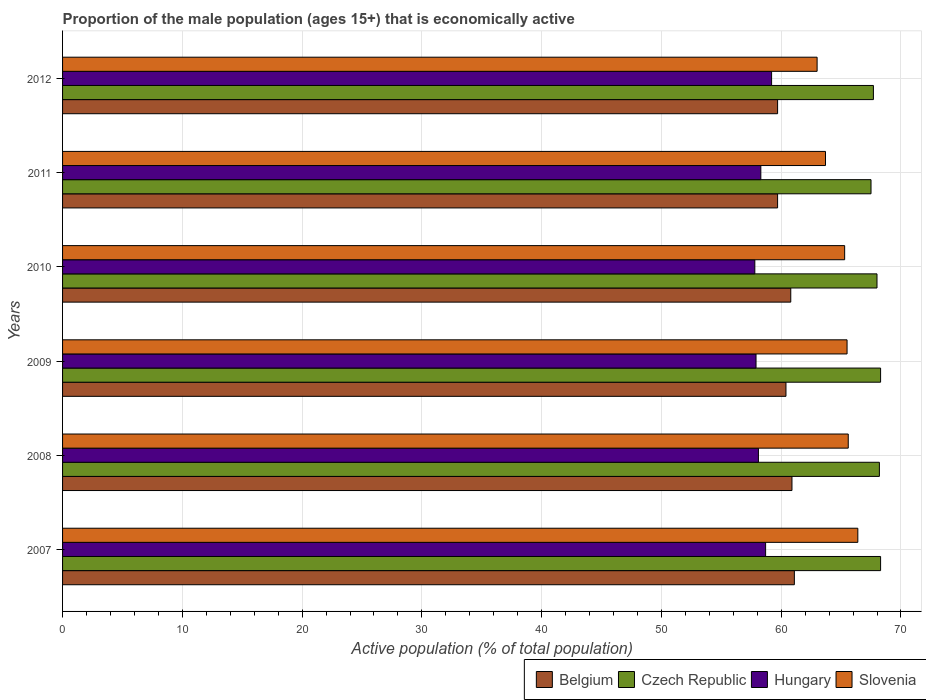Are the number of bars per tick equal to the number of legend labels?
Offer a terse response. Yes. How many bars are there on the 4th tick from the top?
Ensure brevity in your answer.  4. How many bars are there on the 6th tick from the bottom?
Keep it short and to the point. 4. What is the label of the 5th group of bars from the top?
Make the answer very short. 2008. In how many cases, is the number of bars for a given year not equal to the number of legend labels?
Offer a very short reply. 0. What is the proportion of the male population that is economically active in Slovenia in 2010?
Offer a terse response. 65.3. Across all years, what is the maximum proportion of the male population that is economically active in Czech Republic?
Keep it short and to the point. 68.3. Across all years, what is the minimum proportion of the male population that is economically active in Hungary?
Ensure brevity in your answer.  57.8. In which year was the proportion of the male population that is economically active in Slovenia minimum?
Your answer should be compact. 2012. What is the total proportion of the male population that is economically active in Belgium in the graph?
Offer a terse response. 362.6. What is the difference between the proportion of the male population that is economically active in Czech Republic in 2009 and that in 2012?
Offer a very short reply. 0.6. What is the difference between the proportion of the male population that is economically active in Slovenia in 2010 and the proportion of the male population that is economically active in Czech Republic in 2011?
Offer a terse response. -2.2. What is the average proportion of the male population that is economically active in Belgium per year?
Keep it short and to the point. 60.43. In the year 2011, what is the difference between the proportion of the male population that is economically active in Czech Republic and proportion of the male population that is economically active in Belgium?
Provide a short and direct response. 7.8. In how many years, is the proportion of the male population that is economically active in Hungary greater than 36 %?
Offer a very short reply. 6. What is the ratio of the proportion of the male population that is economically active in Hungary in 2011 to that in 2012?
Make the answer very short. 0.98. Is the proportion of the male population that is economically active in Slovenia in 2007 less than that in 2011?
Keep it short and to the point. No. What is the difference between the highest and the second highest proportion of the male population that is economically active in Hungary?
Keep it short and to the point. 0.5. What is the difference between the highest and the lowest proportion of the male population that is economically active in Belgium?
Your response must be concise. 1.4. What does the 1st bar from the bottom in 2012 represents?
Your answer should be compact. Belgium. Is it the case that in every year, the sum of the proportion of the male population that is economically active in Czech Republic and proportion of the male population that is economically active in Hungary is greater than the proportion of the male population that is economically active in Belgium?
Ensure brevity in your answer.  Yes. How many bars are there?
Your answer should be compact. 24. How many years are there in the graph?
Your response must be concise. 6. What is the difference between two consecutive major ticks on the X-axis?
Your answer should be compact. 10. Does the graph contain grids?
Keep it short and to the point. Yes. How many legend labels are there?
Ensure brevity in your answer.  4. How are the legend labels stacked?
Ensure brevity in your answer.  Horizontal. What is the title of the graph?
Ensure brevity in your answer.  Proportion of the male population (ages 15+) that is economically active. What is the label or title of the X-axis?
Your answer should be very brief. Active population (% of total population). What is the label or title of the Y-axis?
Ensure brevity in your answer.  Years. What is the Active population (% of total population) in Belgium in 2007?
Your answer should be compact. 61.1. What is the Active population (% of total population) in Czech Republic in 2007?
Give a very brief answer. 68.3. What is the Active population (% of total population) of Hungary in 2007?
Ensure brevity in your answer.  58.7. What is the Active population (% of total population) in Slovenia in 2007?
Ensure brevity in your answer.  66.4. What is the Active population (% of total population) in Belgium in 2008?
Provide a succinct answer. 60.9. What is the Active population (% of total population) of Czech Republic in 2008?
Your answer should be very brief. 68.2. What is the Active population (% of total population) in Hungary in 2008?
Keep it short and to the point. 58.1. What is the Active population (% of total population) of Slovenia in 2008?
Ensure brevity in your answer.  65.6. What is the Active population (% of total population) of Belgium in 2009?
Offer a very short reply. 60.4. What is the Active population (% of total population) in Czech Republic in 2009?
Ensure brevity in your answer.  68.3. What is the Active population (% of total population) of Hungary in 2009?
Your response must be concise. 57.9. What is the Active population (% of total population) in Slovenia in 2009?
Make the answer very short. 65.5. What is the Active population (% of total population) in Belgium in 2010?
Keep it short and to the point. 60.8. What is the Active population (% of total population) in Hungary in 2010?
Offer a very short reply. 57.8. What is the Active population (% of total population) in Slovenia in 2010?
Make the answer very short. 65.3. What is the Active population (% of total population) of Belgium in 2011?
Provide a succinct answer. 59.7. What is the Active population (% of total population) of Czech Republic in 2011?
Provide a short and direct response. 67.5. What is the Active population (% of total population) of Hungary in 2011?
Offer a terse response. 58.3. What is the Active population (% of total population) of Slovenia in 2011?
Your answer should be very brief. 63.7. What is the Active population (% of total population) in Belgium in 2012?
Your answer should be very brief. 59.7. What is the Active population (% of total population) in Czech Republic in 2012?
Offer a terse response. 67.7. What is the Active population (% of total population) of Hungary in 2012?
Give a very brief answer. 59.2. What is the Active population (% of total population) in Slovenia in 2012?
Give a very brief answer. 63. Across all years, what is the maximum Active population (% of total population) of Belgium?
Offer a very short reply. 61.1. Across all years, what is the maximum Active population (% of total population) in Czech Republic?
Ensure brevity in your answer.  68.3. Across all years, what is the maximum Active population (% of total population) of Hungary?
Your answer should be very brief. 59.2. Across all years, what is the maximum Active population (% of total population) in Slovenia?
Your answer should be very brief. 66.4. Across all years, what is the minimum Active population (% of total population) in Belgium?
Ensure brevity in your answer.  59.7. Across all years, what is the minimum Active population (% of total population) of Czech Republic?
Give a very brief answer. 67.5. Across all years, what is the minimum Active population (% of total population) in Hungary?
Provide a short and direct response. 57.8. Across all years, what is the minimum Active population (% of total population) of Slovenia?
Provide a succinct answer. 63. What is the total Active population (% of total population) in Belgium in the graph?
Provide a short and direct response. 362.6. What is the total Active population (% of total population) of Czech Republic in the graph?
Your response must be concise. 408. What is the total Active population (% of total population) in Hungary in the graph?
Give a very brief answer. 350. What is the total Active population (% of total population) in Slovenia in the graph?
Your answer should be compact. 389.5. What is the difference between the Active population (% of total population) in Hungary in 2007 and that in 2008?
Offer a terse response. 0.6. What is the difference between the Active population (% of total population) of Belgium in 2007 and that in 2009?
Provide a succinct answer. 0.7. What is the difference between the Active population (% of total population) in Belgium in 2007 and that in 2010?
Give a very brief answer. 0.3. What is the difference between the Active population (% of total population) in Slovenia in 2007 and that in 2010?
Provide a short and direct response. 1.1. What is the difference between the Active population (% of total population) in Belgium in 2007 and that in 2011?
Ensure brevity in your answer.  1.4. What is the difference between the Active population (% of total population) of Czech Republic in 2007 and that in 2011?
Provide a succinct answer. 0.8. What is the difference between the Active population (% of total population) in Hungary in 2007 and that in 2011?
Provide a short and direct response. 0.4. What is the difference between the Active population (% of total population) of Belgium in 2007 and that in 2012?
Your answer should be very brief. 1.4. What is the difference between the Active population (% of total population) in Czech Republic in 2007 and that in 2012?
Provide a succinct answer. 0.6. What is the difference between the Active population (% of total population) of Hungary in 2007 and that in 2012?
Offer a terse response. -0.5. What is the difference between the Active population (% of total population) in Slovenia in 2007 and that in 2012?
Offer a very short reply. 3.4. What is the difference between the Active population (% of total population) in Belgium in 2008 and that in 2010?
Make the answer very short. 0.1. What is the difference between the Active population (% of total population) of Belgium in 2008 and that in 2011?
Keep it short and to the point. 1.2. What is the difference between the Active population (% of total population) in Czech Republic in 2008 and that in 2011?
Provide a succinct answer. 0.7. What is the difference between the Active population (% of total population) of Slovenia in 2008 and that in 2011?
Provide a succinct answer. 1.9. What is the difference between the Active population (% of total population) of Belgium in 2008 and that in 2012?
Your response must be concise. 1.2. What is the difference between the Active population (% of total population) in Czech Republic in 2008 and that in 2012?
Your response must be concise. 0.5. What is the difference between the Active population (% of total population) in Slovenia in 2008 and that in 2012?
Ensure brevity in your answer.  2.6. What is the difference between the Active population (% of total population) in Hungary in 2009 and that in 2010?
Make the answer very short. 0.1. What is the difference between the Active population (% of total population) in Czech Republic in 2009 and that in 2011?
Offer a terse response. 0.8. What is the difference between the Active population (% of total population) in Czech Republic in 2009 and that in 2012?
Offer a very short reply. 0.6. What is the difference between the Active population (% of total population) in Hungary in 2009 and that in 2012?
Provide a succinct answer. -1.3. What is the difference between the Active population (% of total population) of Belgium in 2010 and that in 2011?
Keep it short and to the point. 1.1. What is the difference between the Active population (% of total population) of Hungary in 2010 and that in 2011?
Provide a short and direct response. -0.5. What is the difference between the Active population (% of total population) in Belgium in 2010 and that in 2012?
Ensure brevity in your answer.  1.1. What is the difference between the Active population (% of total population) in Czech Republic in 2010 and that in 2012?
Your answer should be compact. 0.3. What is the difference between the Active population (% of total population) in Hungary in 2010 and that in 2012?
Keep it short and to the point. -1.4. What is the difference between the Active population (% of total population) of Belgium in 2011 and that in 2012?
Offer a very short reply. 0. What is the difference between the Active population (% of total population) of Czech Republic in 2011 and that in 2012?
Ensure brevity in your answer.  -0.2. What is the difference between the Active population (% of total population) in Slovenia in 2011 and that in 2012?
Make the answer very short. 0.7. What is the difference between the Active population (% of total population) of Belgium in 2007 and the Active population (% of total population) of Czech Republic in 2008?
Provide a succinct answer. -7.1. What is the difference between the Active population (% of total population) in Belgium in 2007 and the Active population (% of total population) in Slovenia in 2008?
Provide a short and direct response. -4.5. What is the difference between the Active population (% of total population) of Czech Republic in 2007 and the Active population (% of total population) of Slovenia in 2008?
Offer a very short reply. 2.7. What is the difference between the Active population (% of total population) in Belgium in 2007 and the Active population (% of total population) in Czech Republic in 2009?
Your answer should be compact. -7.2. What is the difference between the Active population (% of total population) in Belgium in 2007 and the Active population (% of total population) in Slovenia in 2009?
Offer a terse response. -4.4. What is the difference between the Active population (% of total population) in Czech Republic in 2007 and the Active population (% of total population) in Hungary in 2009?
Make the answer very short. 10.4. What is the difference between the Active population (% of total population) in Czech Republic in 2007 and the Active population (% of total population) in Slovenia in 2009?
Your answer should be compact. 2.8. What is the difference between the Active population (% of total population) in Belgium in 2007 and the Active population (% of total population) in Czech Republic in 2010?
Offer a very short reply. -6.9. What is the difference between the Active population (% of total population) of Hungary in 2007 and the Active population (% of total population) of Slovenia in 2010?
Your answer should be very brief. -6.6. What is the difference between the Active population (% of total population) of Czech Republic in 2007 and the Active population (% of total population) of Hungary in 2011?
Give a very brief answer. 10. What is the difference between the Active population (% of total population) in Czech Republic in 2007 and the Active population (% of total population) in Slovenia in 2011?
Offer a terse response. 4.6. What is the difference between the Active population (% of total population) of Hungary in 2007 and the Active population (% of total population) of Slovenia in 2011?
Give a very brief answer. -5. What is the difference between the Active population (% of total population) in Belgium in 2007 and the Active population (% of total population) in Czech Republic in 2012?
Your answer should be compact. -6.6. What is the difference between the Active population (% of total population) in Belgium in 2007 and the Active population (% of total population) in Hungary in 2012?
Offer a very short reply. 1.9. What is the difference between the Active population (% of total population) in Belgium in 2007 and the Active population (% of total population) in Slovenia in 2012?
Give a very brief answer. -1.9. What is the difference between the Active population (% of total population) in Hungary in 2007 and the Active population (% of total population) in Slovenia in 2012?
Provide a short and direct response. -4.3. What is the difference between the Active population (% of total population) in Belgium in 2008 and the Active population (% of total population) in Czech Republic in 2009?
Offer a very short reply. -7.4. What is the difference between the Active population (% of total population) of Belgium in 2008 and the Active population (% of total population) of Slovenia in 2009?
Your response must be concise. -4.6. What is the difference between the Active population (% of total population) of Czech Republic in 2008 and the Active population (% of total population) of Hungary in 2009?
Offer a very short reply. 10.3. What is the difference between the Active population (% of total population) of Belgium in 2008 and the Active population (% of total population) of Czech Republic in 2010?
Provide a short and direct response. -7.1. What is the difference between the Active population (% of total population) in Belgium in 2008 and the Active population (% of total population) in Hungary in 2010?
Provide a succinct answer. 3.1. What is the difference between the Active population (% of total population) in Belgium in 2008 and the Active population (% of total population) in Slovenia in 2010?
Keep it short and to the point. -4.4. What is the difference between the Active population (% of total population) in Czech Republic in 2008 and the Active population (% of total population) in Hungary in 2010?
Your response must be concise. 10.4. What is the difference between the Active population (% of total population) of Hungary in 2008 and the Active population (% of total population) of Slovenia in 2010?
Keep it short and to the point. -7.2. What is the difference between the Active population (% of total population) in Belgium in 2008 and the Active population (% of total population) in Hungary in 2011?
Offer a very short reply. 2.6. What is the difference between the Active population (% of total population) in Czech Republic in 2008 and the Active population (% of total population) in Slovenia in 2011?
Offer a very short reply. 4.5. What is the difference between the Active population (% of total population) in Hungary in 2008 and the Active population (% of total population) in Slovenia in 2011?
Give a very brief answer. -5.6. What is the difference between the Active population (% of total population) in Belgium in 2008 and the Active population (% of total population) in Czech Republic in 2012?
Offer a terse response. -6.8. What is the difference between the Active population (% of total population) in Belgium in 2008 and the Active population (% of total population) in Slovenia in 2012?
Make the answer very short. -2.1. What is the difference between the Active population (% of total population) of Czech Republic in 2008 and the Active population (% of total population) of Hungary in 2012?
Offer a terse response. 9. What is the difference between the Active population (% of total population) in Belgium in 2009 and the Active population (% of total population) in Czech Republic in 2010?
Provide a short and direct response. -7.6. What is the difference between the Active population (% of total population) in Belgium in 2009 and the Active population (% of total population) in Slovenia in 2010?
Offer a terse response. -4.9. What is the difference between the Active population (% of total population) of Czech Republic in 2009 and the Active population (% of total population) of Hungary in 2010?
Offer a terse response. 10.5. What is the difference between the Active population (% of total population) of Czech Republic in 2009 and the Active population (% of total population) of Slovenia in 2010?
Make the answer very short. 3. What is the difference between the Active population (% of total population) in Belgium in 2009 and the Active population (% of total population) in Hungary in 2011?
Provide a succinct answer. 2.1. What is the difference between the Active population (% of total population) of Czech Republic in 2009 and the Active population (% of total population) of Slovenia in 2011?
Provide a short and direct response. 4.6. What is the difference between the Active population (% of total population) of Belgium in 2009 and the Active population (% of total population) of Slovenia in 2012?
Provide a succinct answer. -2.6. What is the difference between the Active population (% of total population) in Czech Republic in 2009 and the Active population (% of total population) in Hungary in 2012?
Offer a terse response. 9.1. What is the difference between the Active population (% of total population) of Belgium in 2010 and the Active population (% of total population) of Slovenia in 2011?
Offer a terse response. -2.9. What is the difference between the Active population (% of total population) in Czech Republic in 2010 and the Active population (% of total population) in Hungary in 2011?
Ensure brevity in your answer.  9.7. What is the difference between the Active population (% of total population) in Czech Republic in 2010 and the Active population (% of total population) in Slovenia in 2011?
Your response must be concise. 4.3. What is the difference between the Active population (% of total population) in Hungary in 2010 and the Active population (% of total population) in Slovenia in 2011?
Your response must be concise. -5.9. What is the difference between the Active population (% of total population) of Belgium in 2010 and the Active population (% of total population) of Czech Republic in 2012?
Provide a succinct answer. -6.9. What is the difference between the Active population (% of total population) of Belgium in 2010 and the Active population (% of total population) of Hungary in 2012?
Offer a very short reply. 1.6. What is the difference between the Active population (% of total population) of Czech Republic in 2010 and the Active population (% of total population) of Slovenia in 2012?
Keep it short and to the point. 5. What is the difference between the Active population (% of total population) in Hungary in 2010 and the Active population (% of total population) in Slovenia in 2012?
Provide a succinct answer. -5.2. What is the difference between the Active population (% of total population) in Belgium in 2011 and the Active population (% of total population) in Slovenia in 2012?
Provide a short and direct response. -3.3. What is the difference between the Active population (% of total population) in Czech Republic in 2011 and the Active population (% of total population) in Hungary in 2012?
Your answer should be compact. 8.3. What is the average Active population (% of total population) in Belgium per year?
Make the answer very short. 60.43. What is the average Active population (% of total population) of Czech Republic per year?
Provide a succinct answer. 68. What is the average Active population (% of total population) of Hungary per year?
Keep it short and to the point. 58.33. What is the average Active population (% of total population) of Slovenia per year?
Provide a short and direct response. 64.92. In the year 2007, what is the difference between the Active population (% of total population) of Belgium and Active population (% of total population) of Hungary?
Your answer should be compact. 2.4. In the year 2007, what is the difference between the Active population (% of total population) in Czech Republic and Active population (% of total population) in Slovenia?
Provide a short and direct response. 1.9. In the year 2008, what is the difference between the Active population (% of total population) of Belgium and Active population (% of total population) of Hungary?
Provide a succinct answer. 2.8. In the year 2008, what is the difference between the Active population (% of total population) of Czech Republic and Active population (% of total population) of Slovenia?
Offer a very short reply. 2.6. In the year 2008, what is the difference between the Active population (% of total population) of Hungary and Active population (% of total population) of Slovenia?
Offer a very short reply. -7.5. In the year 2009, what is the difference between the Active population (% of total population) in Belgium and Active population (% of total population) in Czech Republic?
Your answer should be very brief. -7.9. In the year 2009, what is the difference between the Active population (% of total population) of Belgium and Active population (% of total population) of Slovenia?
Your answer should be compact. -5.1. In the year 2009, what is the difference between the Active population (% of total population) in Czech Republic and Active population (% of total population) in Hungary?
Make the answer very short. 10.4. In the year 2009, what is the difference between the Active population (% of total population) in Czech Republic and Active population (% of total population) in Slovenia?
Your answer should be very brief. 2.8. In the year 2009, what is the difference between the Active population (% of total population) in Hungary and Active population (% of total population) in Slovenia?
Keep it short and to the point. -7.6. In the year 2010, what is the difference between the Active population (% of total population) of Belgium and Active population (% of total population) of Slovenia?
Keep it short and to the point. -4.5. In the year 2010, what is the difference between the Active population (% of total population) of Czech Republic and Active population (% of total population) of Slovenia?
Ensure brevity in your answer.  2.7. In the year 2011, what is the difference between the Active population (% of total population) of Belgium and Active population (% of total population) of Hungary?
Ensure brevity in your answer.  1.4. In the year 2011, what is the difference between the Active population (% of total population) of Czech Republic and Active population (% of total population) of Hungary?
Offer a terse response. 9.2. In the year 2012, what is the difference between the Active population (% of total population) of Belgium and Active population (% of total population) of Czech Republic?
Your response must be concise. -8. What is the ratio of the Active population (% of total population) in Belgium in 2007 to that in 2008?
Ensure brevity in your answer.  1. What is the ratio of the Active population (% of total population) in Hungary in 2007 to that in 2008?
Offer a very short reply. 1.01. What is the ratio of the Active population (% of total population) in Slovenia in 2007 to that in 2008?
Offer a terse response. 1.01. What is the ratio of the Active population (% of total population) in Belgium in 2007 to that in 2009?
Offer a terse response. 1.01. What is the ratio of the Active population (% of total population) of Hungary in 2007 to that in 2009?
Give a very brief answer. 1.01. What is the ratio of the Active population (% of total population) in Slovenia in 2007 to that in 2009?
Give a very brief answer. 1.01. What is the ratio of the Active population (% of total population) of Hungary in 2007 to that in 2010?
Offer a terse response. 1.02. What is the ratio of the Active population (% of total population) of Slovenia in 2007 to that in 2010?
Provide a short and direct response. 1.02. What is the ratio of the Active population (% of total population) of Belgium in 2007 to that in 2011?
Provide a short and direct response. 1.02. What is the ratio of the Active population (% of total population) of Czech Republic in 2007 to that in 2011?
Your response must be concise. 1.01. What is the ratio of the Active population (% of total population) of Slovenia in 2007 to that in 2011?
Your answer should be compact. 1.04. What is the ratio of the Active population (% of total population) of Belgium in 2007 to that in 2012?
Your answer should be compact. 1.02. What is the ratio of the Active population (% of total population) of Czech Republic in 2007 to that in 2012?
Ensure brevity in your answer.  1.01. What is the ratio of the Active population (% of total population) of Hungary in 2007 to that in 2012?
Offer a terse response. 0.99. What is the ratio of the Active population (% of total population) of Slovenia in 2007 to that in 2012?
Keep it short and to the point. 1.05. What is the ratio of the Active population (% of total population) of Belgium in 2008 to that in 2009?
Keep it short and to the point. 1.01. What is the ratio of the Active population (% of total population) of Slovenia in 2008 to that in 2009?
Provide a short and direct response. 1. What is the ratio of the Active population (% of total population) of Belgium in 2008 to that in 2010?
Provide a succinct answer. 1. What is the ratio of the Active population (% of total population) in Czech Republic in 2008 to that in 2010?
Your answer should be very brief. 1. What is the ratio of the Active population (% of total population) in Hungary in 2008 to that in 2010?
Ensure brevity in your answer.  1.01. What is the ratio of the Active population (% of total population) of Belgium in 2008 to that in 2011?
Offer a very short reply. 1.02. What is the ratio of the Active population (% of total population) of Czech Republic in 2008 to that in 2011?
Offer a terse response. 1.01. What is the ratio of the Active population (% of total population) in Hungary in 2008 to that in 2011?
Your answer should be very brief. 1. What is the ratio of the Active population (% of total population) in Slovenia in 2008 to that in 2011?
Make the answer very short. 1.03. What is the ratio of the Active population (% of total population) of Belgium in 2008 to that in 2012?
Your answer should be compact. 1.02. What is the ratio of the Active population (% of total population) in Czech Republic in 2008 to that in 2012?
Offer a terse response. 1.01. What is the ratio of the Active population (% of total population) in Hungary in 2008 to that in 2012?
Your answer should be very brief. 0.98. What is the ratio of the Active population (% of total population) of Slovenia in 2008 to that in 2012?
Keep it short and to the point. 1.04. What is the ratio of the Active population (% of total population) in Czech Republic in 2009 to that in 2010?
Keep it short and to the point. 1. What is the ratio of the Active population (% of total population) in Belgium in 2009 to that in 2011?
Keep it short and to the point. 1.01. What is the ratio of the Active population (% of total population) in Czech Republic in 2009 to that in 2011?
Your answer should be very brief. 1.01. What is the ratio of the Active population (% of total population) of Hungary in 2009 to that in 2011?
Provide a succinct answer. 0.99. What is the ratio of the Active population (% of total population) in Slovenia in 2009 to that in 2011?
Your response must be concise. 1.03. What is the ratio of the Active population (% of total population) of Belgium in 2009 to that in 2012?
Offer a terse response. 1.01. What is the ratio of the Active population (% of total population) of Czech Republic in 2009 to that in 2012?
Provide a succinct answer. 1.01. What is the ratio of the Active population (% of total population) of Slovenia in 2009 to that in 2012?
Your response must be concise. 1.04. What is the ratio of the Active population (% of total population) of Belgium in 2010 to that in 2011?
Your response must be concise. 1.02. What is the ratio of the Active population (% of total population) in Czech Republic in 2010 to that in 2011?
Your response must be concise. 1.01. What is the ratio of the Active population (% of total population) of Hungary in 2010 to that in 2011?
Ensure brevity in your answer.  0.99. What is the ratio of the Active population (% of total population) in Slovenia in 2010 to that in 2011?
Keep it short and to the point. 1.03. What is the ratio of the Active population (% of total population) in Belgium in 2010 to that in 2012?
Your answer should be compact. 1.02. What is the ratio of the Active population (% of total population) in Hungary in 2010 to that in 2012?
Your answer should be very brief. 0.98. What is the ratio of the Active population (% of total population) in Slovenia in 2010 to that in 2012?
Ensure brevity in your answer.  1.04. What is the ratio of the Active population (% of total population) in Slovenia in 2011 to that in 2012?
Provide a short and direct response. 1.01. What is the difference between the highest and the second highest Active population (% of total population) in Hungary?
Provide a short and direct response. 0.5. What is the difference between the highest and the second highest Active population (% of total population) in Slovenia?
Offer a terse response. 0.8. What is the difference between the highest and the lowest Active population (% of total population) in Belgium?
Offer a terse response. 1.4. What is the difference between the highest and the lowest Active population (% of total population) in Hungary?
Ensure brevity in your answer.  1.4. 